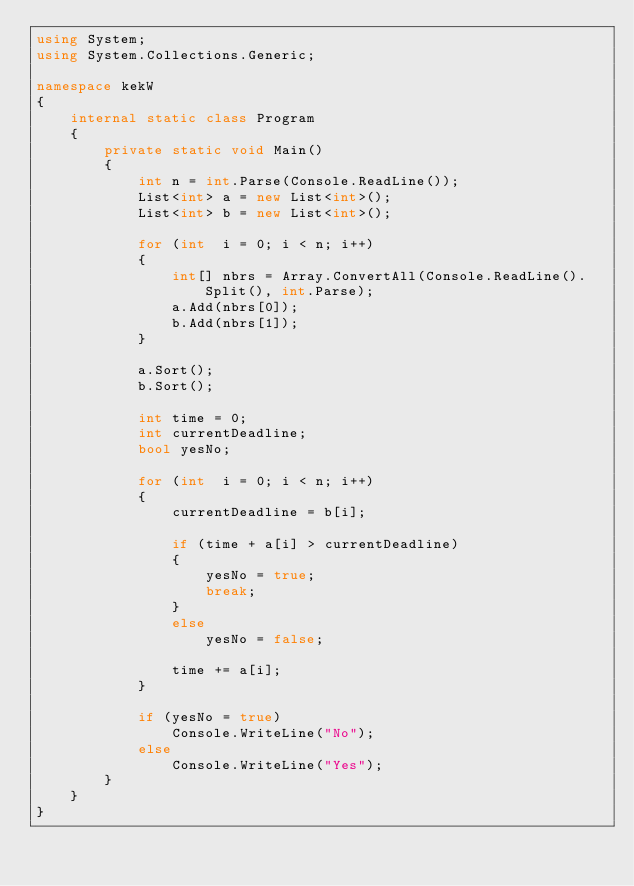Convert code to text. <code><loc_0><loc_0><loc_500><loc_500><_C#_>using System;
using System.Collections.Generic;

namespace kekW
{
    internal static class Program
    {
        private static void Main()
        {
            int n = int.Parse(Console.ReadLine());
            List<int> a = new List<int>();
            List<int> b = new List<int>();

            for (int  i = 0; i < n; i++)
            {
                int[] nbrs = Array.ConvertAll(Console.ReadLine().Split(), int.Parse);
                a.Add(nbrs[0]);
                b.Add(nbrs[1]);
            }

            a.Sort();
            b.Sort();

            int time = 0;
            int currentDeadline;
            bool yesNo;

            for (int  i = 0; i < n; i++)
            {                
                currentDeadline = b[i];

                if (time + a[i] > currentDeadline)
                {
                    yesNo = true;
                    break;
                }
                else
                    yesNo = false;

                time += a[i];
            }

            if (yesNo = true)
                Console.WriteLine("No");
            else
                Console.WriteLine("Yes");
        }
    }
}
</code> 